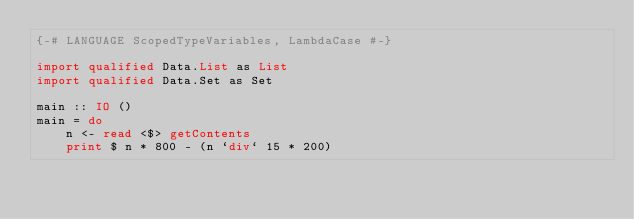<code> <loc_0><loc_0><loc_500><loc_500><_Haskell_>{-# LANGUAGE ScopedTypeVariables, LambdaCase #-}

import qualified Data.List as List
import qualified Data.Set as Set

main :: IO ()
main = do
    n <- read <$> getContents
    print $ n * 800 - (n `div` 15 * 200)</code> 